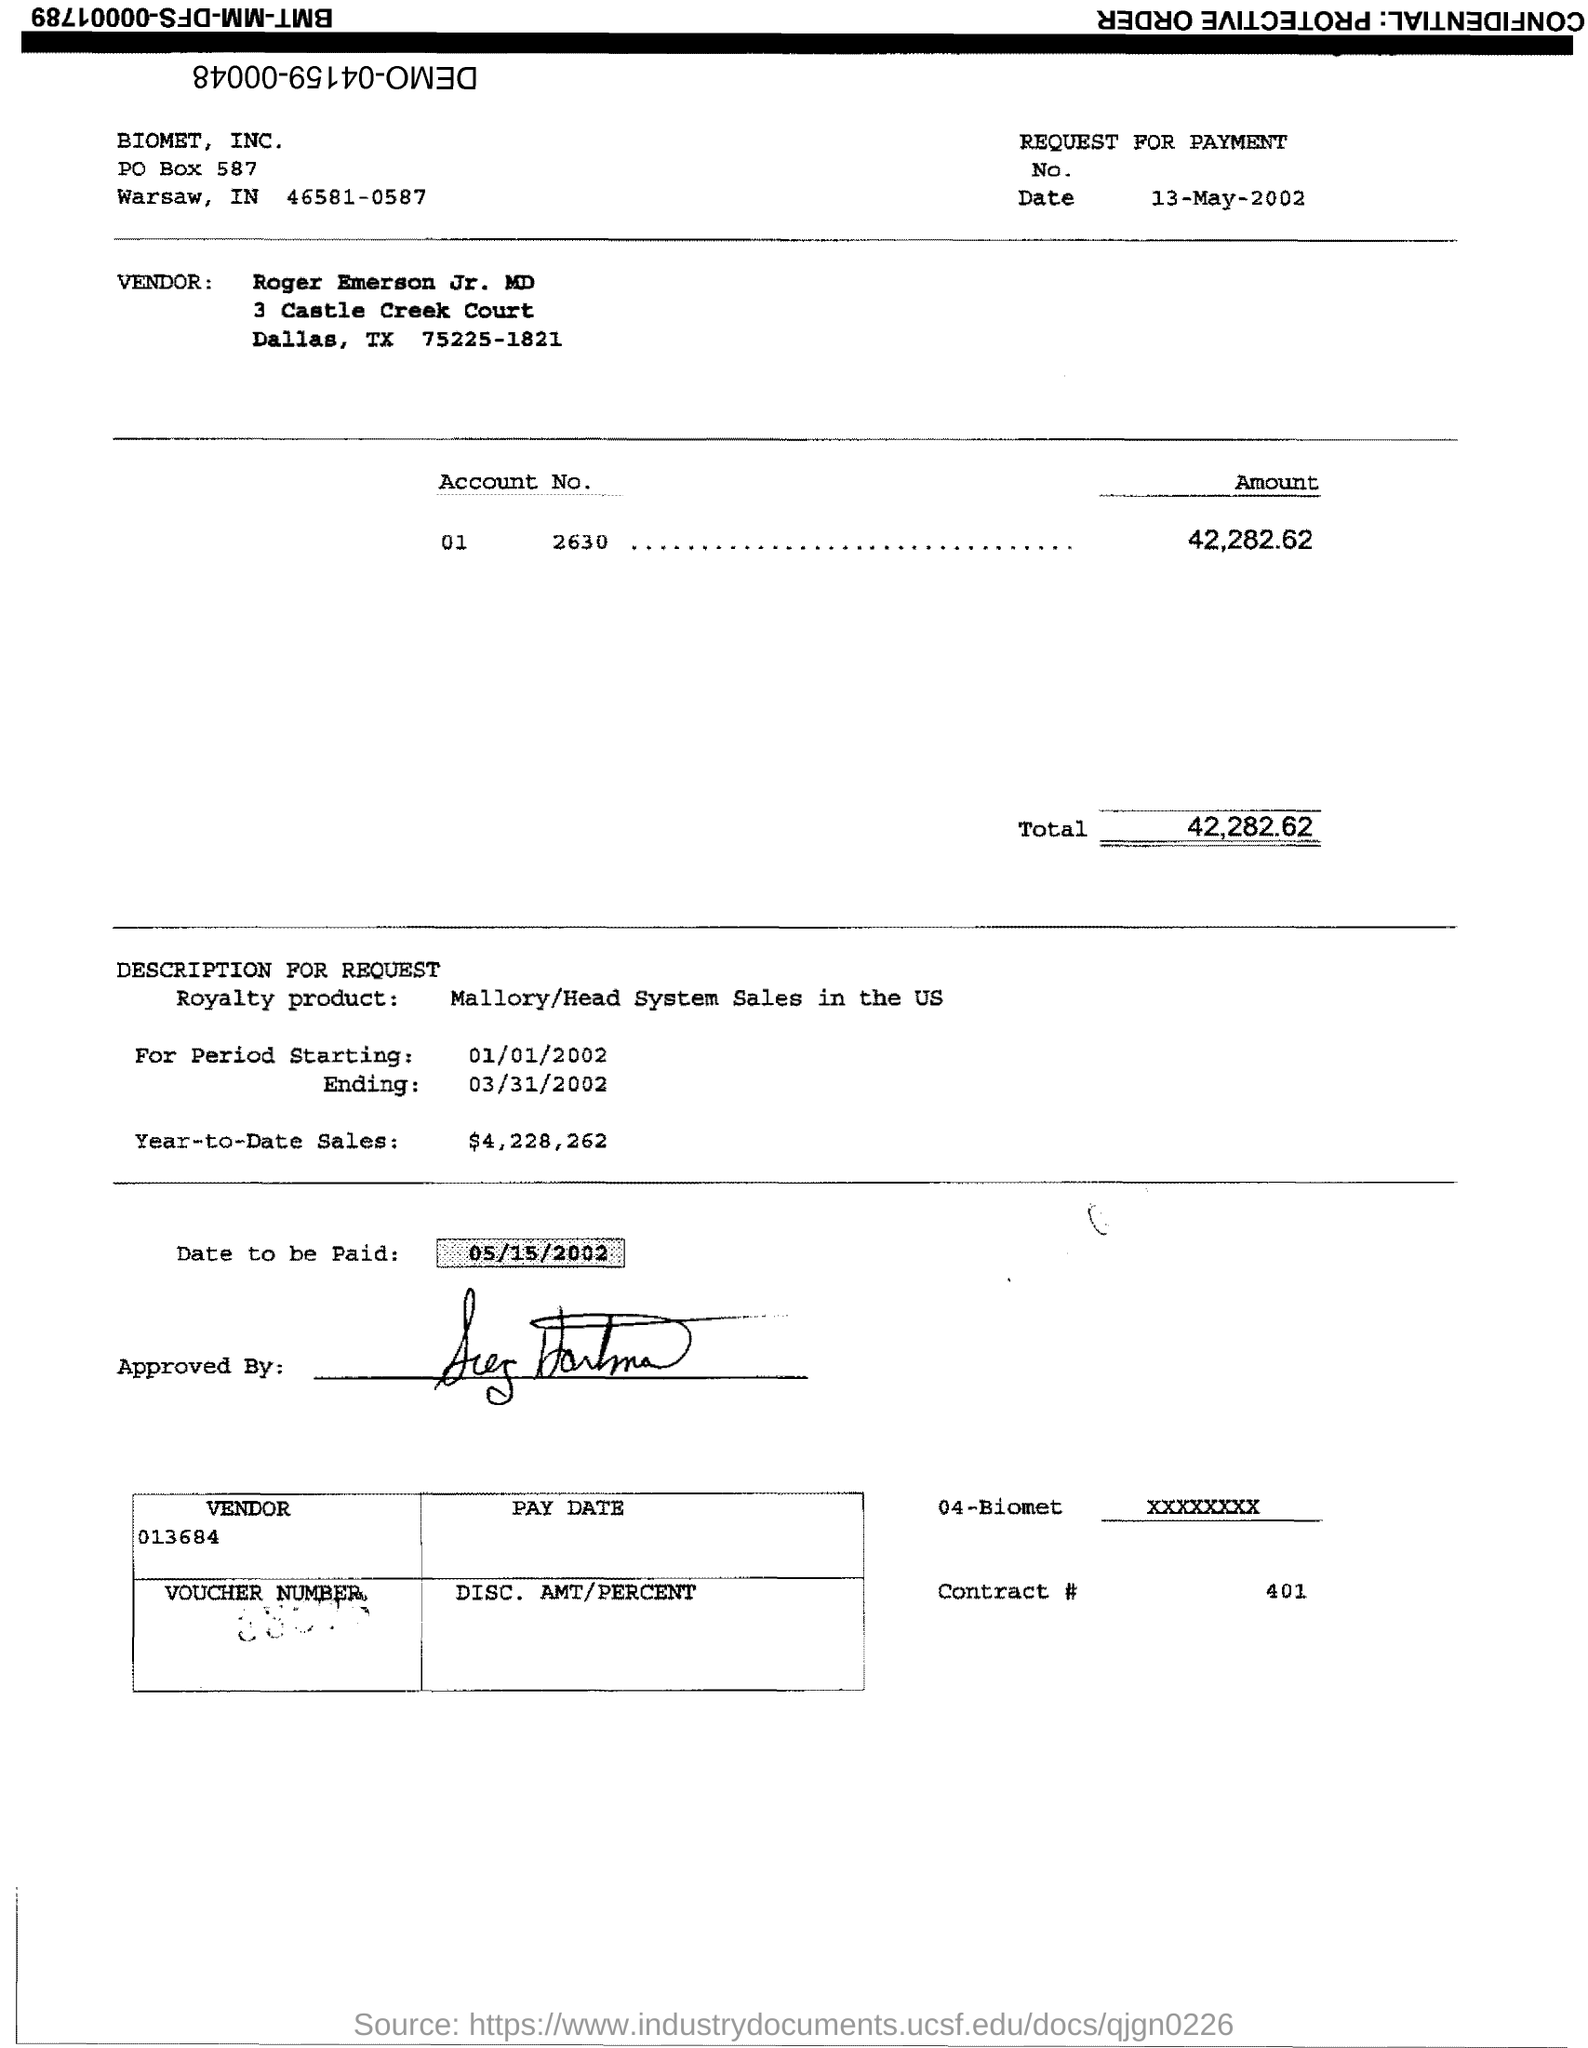What additional information can you provide about the vendor mentioned in the document? The vendor is named Roger Emerson Jr. MD, with an address listed as 3 Castle Creek Court, Dallas, TX 75225-1821. No further personal or business details can be derived from the document. How would you describe the overall condition of the document? The document appears to be an official payment request that has been scanned from a physical copy. It shows signs of typical handling and wear, with slight creases and staple marks. 